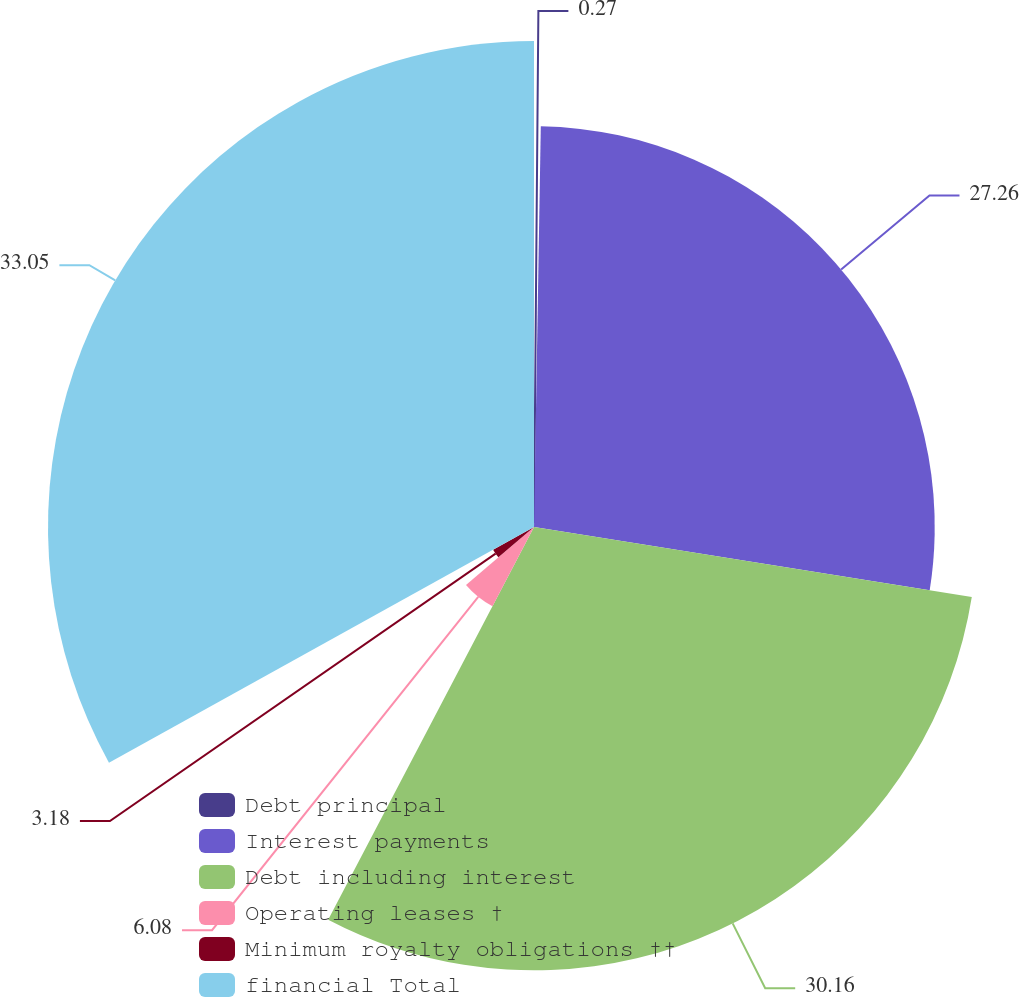<chart> <loc_0><loc_0><loc_500><loc_500><pie_chart><fcel>Debt principal<fcel>Interest payments<fcel>Debt including interest<fcel>Operating leases †<fcel>Minimum royalty obligations ††<fcel>financial Total<nl><fcel>0.27%<fcel>27.26%<fcel>30.16%<fcel>6.08%<fcel>3.18%<fcel>33.06%<nl></chart> 